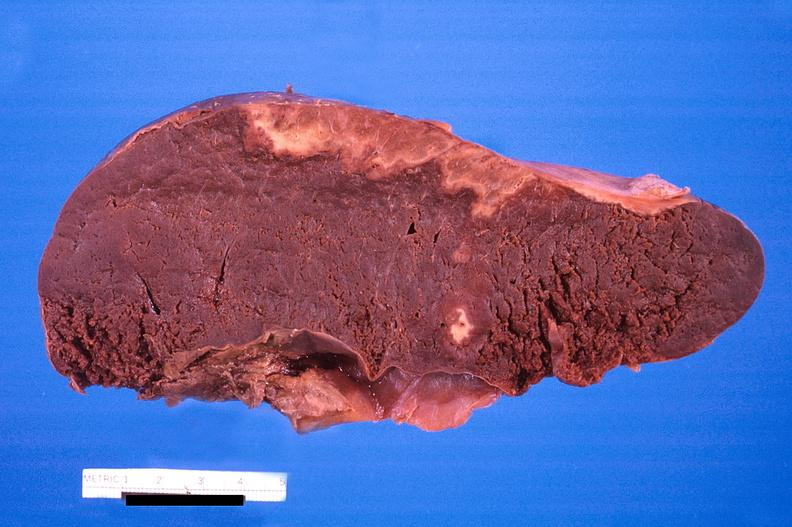what disseminated intravascular coagulation?
Answer the question using a single word or phrase. Spleen, infarcts, 